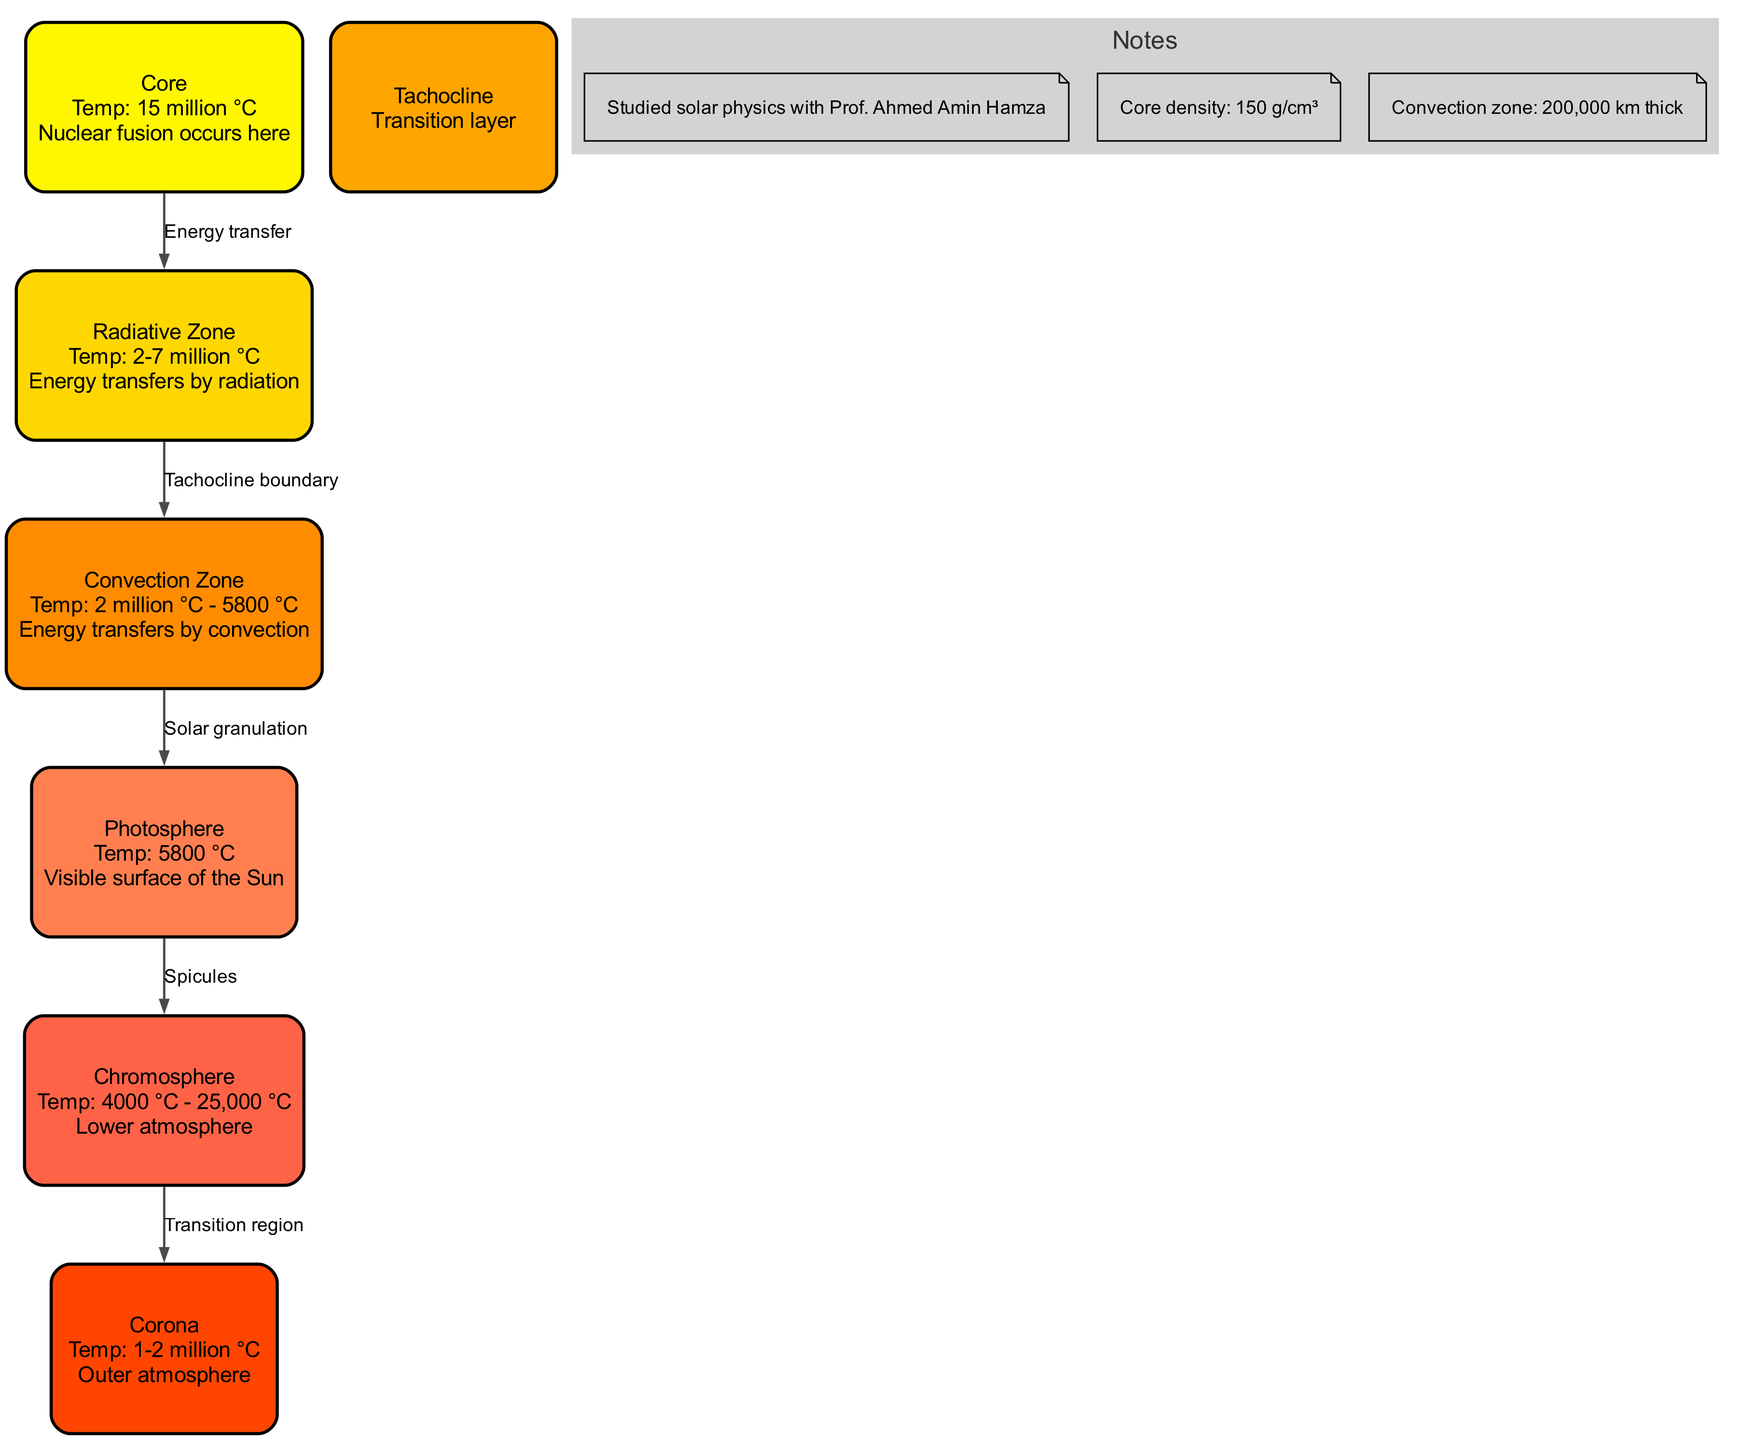What is the temperature of the Sun's core? The diagram indicates that the temperature in the Sun's core is 15 million °C, as specified directly in the information for the "Core" layer.
Answer: 15 million °C What occurs in the radiative zone? The description for the "Radiative Zone" layer states that energy transfers by radiation occurs here. This constitutes the function of this layer as depicted in the diagram.
Answer: Energy transfers by radiation Which layer of the Sun is the visible surface? According to the "Photosphere" layer description in the diagram, it is identified as the visible surface of the Sun.
Answer: Photosphere What is the temperature range of the chromosphere? The information in the diagram shows that the temperature of the "Chromosphere" ranges from 4000 °C to 25,000 °C. This is clearly noted under the chromosphere layer.
Answer: 4000 °C - 25,000 °C How many layers are there in total? By counting the number of distinct layers specified in the diagram, there are seven layers listed. This includes the layers from the core to the corona.
Answer: 7 What is the layer between the radiative zone and the convection zone called? The transition layer connecting the radiative zone to the convection zone is labeled as "Tachocline" in the diagram.
Answer: Tachocline In which zone does energy transfer by convection occur? The "Convection Zone" is specifically identified as the layer where energy transfers by convection, as stated in the layer's description.
Answer: Convection Zone What is the density of the core? The notes section of the diagram specifies that the density of the Sun's core is 150 g/cm³, providing a clear answer to this question.
Answer: 150 g/cm³ What connects the convection zone to the photosphere? The diagram indicates that the connection between the "Convection Zone" and the "Photosphere" is labeled as "Solar granulation." This indicates the nature of their relationship.
Answer: Solar granulation 